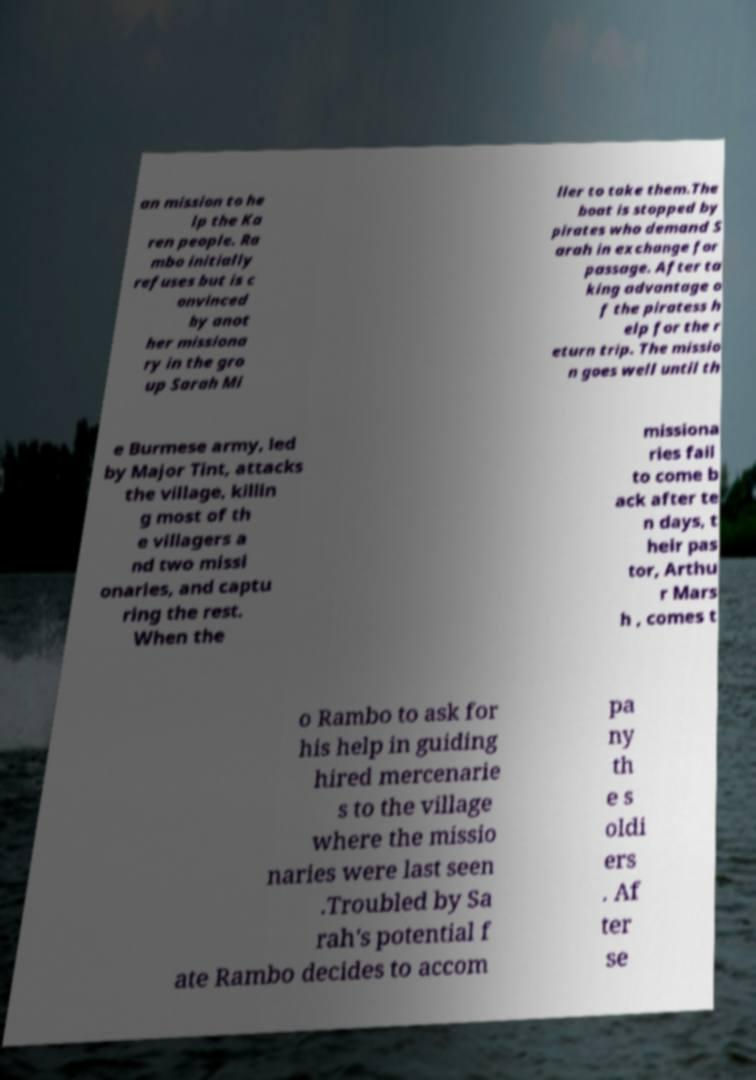For documentation purposes, I need the text within this image transcribed. Could you provide that? an mission to he lp the Ka ren people. Ra mbo initially refuses but is c onvinced by anot her missiona ry in the gro up Sarah Mi ller to take them.The boat is stopped by pirates who demand S arah in exchange for passage. After ta king advantage o f the piratess h elp for the r eturn trip. The missio n goes well until th e Burmese army, led by Major Tint, attacks the village, killin g most of th e villagers a nd two missi onaries, and captu ring the rest. When the missiona ries fail to come b ack after te n days, t heir pas tor, Arthu r Mars h , comes t o Rambo to ask for his help in guiding hired mercenarie s to the village where the missio naries were last seen .Troubled by Sa rah's potential f ate Rambo decides to accom pa ny th e s oldi ers . Af ter se 